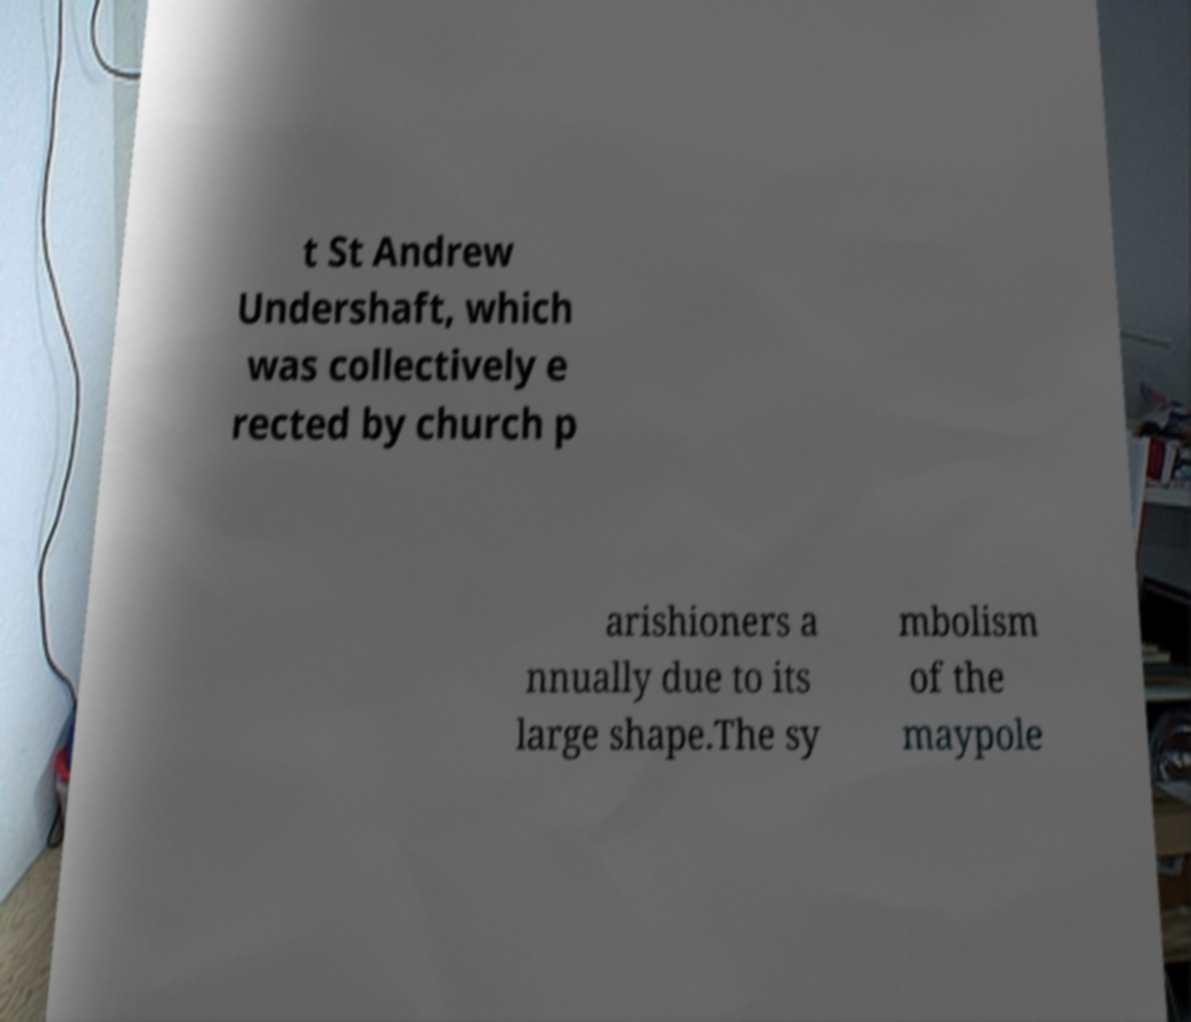What messages or text are displayed in this image? I need them in a readable, typed format. t St Andrew Undershaft, which was collectively e rected by church p arishioners a nnually due to its large shape.The sy mbolism of the maypole 